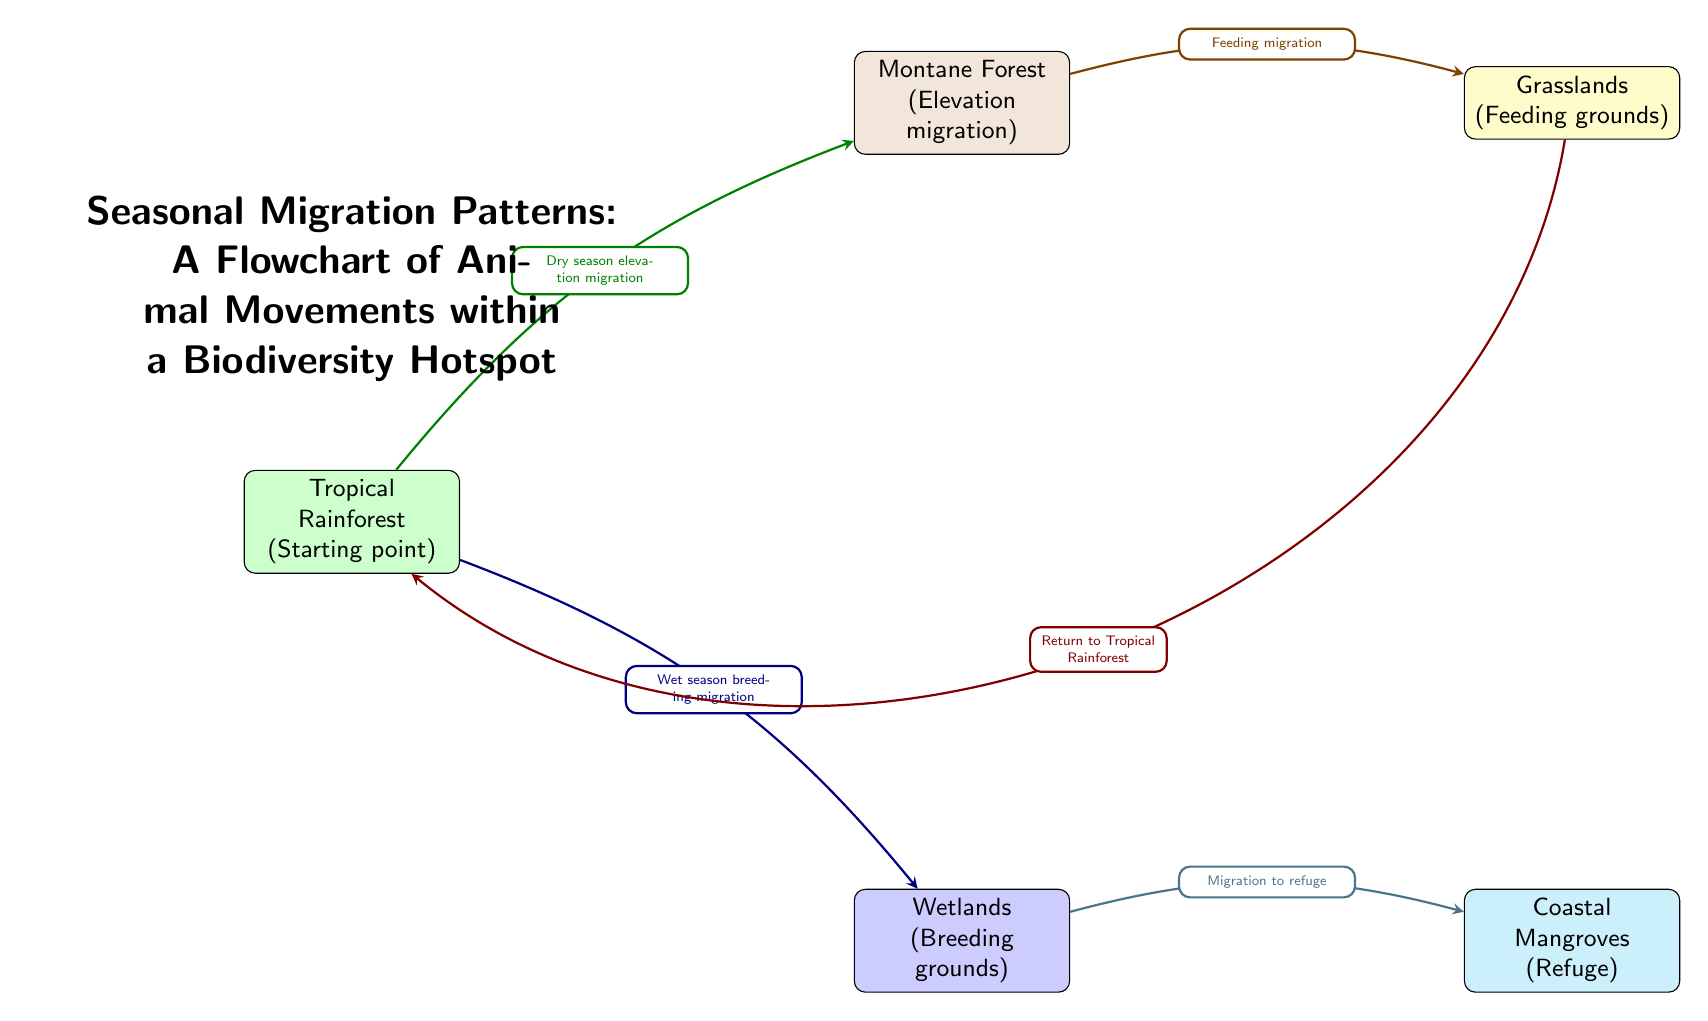What is the starting point of the migration pattern? The starting point is indicated in the diagram as the first node labeled "Tropical Rainforest", which serves as the origin for various migratory paths.
Answer: Tropical Rainforest What is the destination for the breeding migration? The destination for breeding migration is identified in the diagram as the "Wetlands", indicating this is where animals migrate during the wet season for breeding purposes.
Answer: Wetlands How many nodes are in the diagram? By counting the nodes represented, there are five nodes in total: Tropical Rainforest, Montane Forest, Wetlands, Grasslands, and Coastal Mangroves.
Answer: 5 What type of migration occurs from the Tropical Rainforest to the Montane Forest? The migration type described between these two nodes, as shown in the diagram, is labeled "Dry season elevation migration", showcasing the seasonal movement patterns.
Answer: Dry season elevation migration What is the relationship between Grasslands and Tropical Rainforest? The relationship is expressed through the return migration path labeled "Return to Tropical Rainforest", illustrating the cyclical nature of animal movements back to their original habitat after feeding.
Answer: Return to Tropical Rainforest What do animals migrate to the Coastal Mangroves for? The purpose of migratory movement towards Coastal Mangroves is indicated in the diagram as finding "Refuge", emphasizing the importance of this habitat during their migration.
Answer: Refuge Which node represents the feeding grounds? In the diagram, the node that represents the feeding grounds is labeled "Grasslands", indicating where animals seek food during their migration.
Answer: Grasslands What type of migration occurs from Montane Forest to Grasslands? The diagram specifies the type of migration as "Feeding migration", reflecting the movement from one node to another in search of food resources.
Answer: Feeding migration What seasonal event prompts migration from Wetlands to Coastal Mangroves? The migration event indicated in the diagram is described as "Migration to refuge," signifying the movement that occurs due to seasonal changes related to habitat safety.
Answer: Migration to refuge 